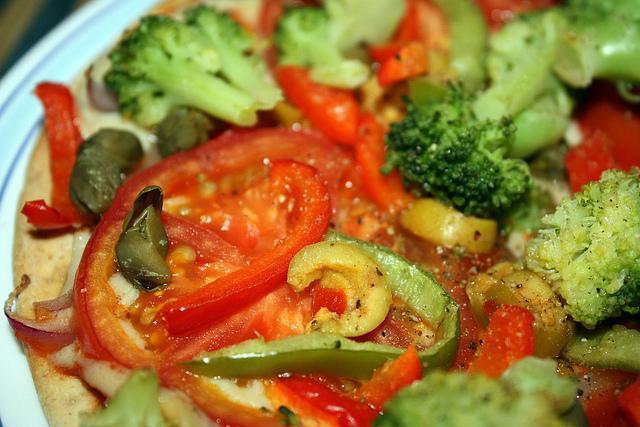How many broccolis are there?
Give a very brief answer. 6. 